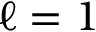Convert formula to latex. <formula><loc_0><loc_0><loc_500><loc_500>\ell = 1</formula> 